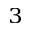Convert formula to latex. <formula><loc_0><loc_0><loc_500><loc_500>^ { 3 }</formula> 